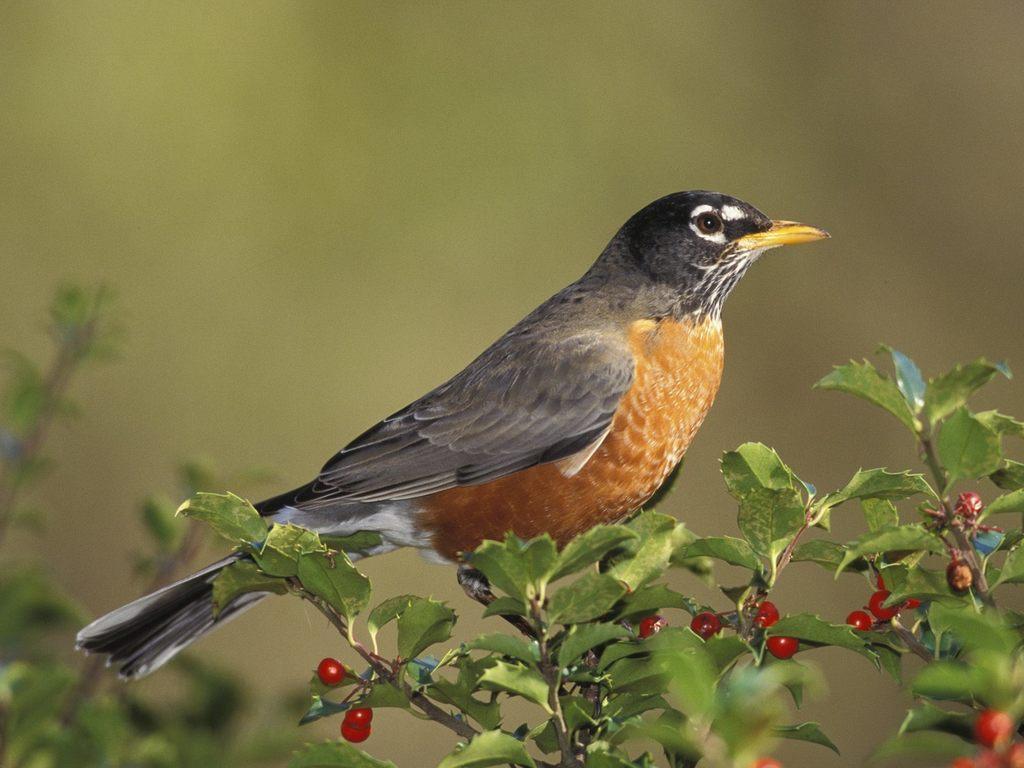Describe this image in one or two sentences. In the picture we can see a plant with small fruits and on it we can see a bird standing. 